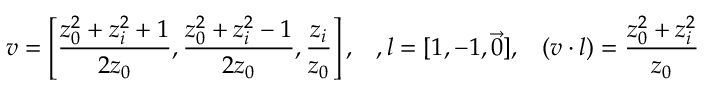<formula> <loc_0><loc_0><loc_500><loc_500>v = \left [ { \frac { z _ { 0 } ^ { 2 } + z _ { i } ^ { 2 } + 1 } { 2 z _ { 0 } } } , { \frac { z _ { 0 } ^ { 2 } + z _ { i } ^ { 2 } - 1 } { 2 z _ { 0 } } } , { \frac { z _ { i } } { z _ { 0 } } } \right ] , \, , l = [ 1 , - 1 , \vec { 0 } ] , \, ( v \cdot l ) = { \frac { z _ { 0 } ^ { 2 } + z _ { i } ^ { 2 } } { z _ { 0 } } }</formula> 